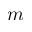Convert formula to latex. <formula><loc_0><loc_0><loc_500><loc_500>m</formula> 